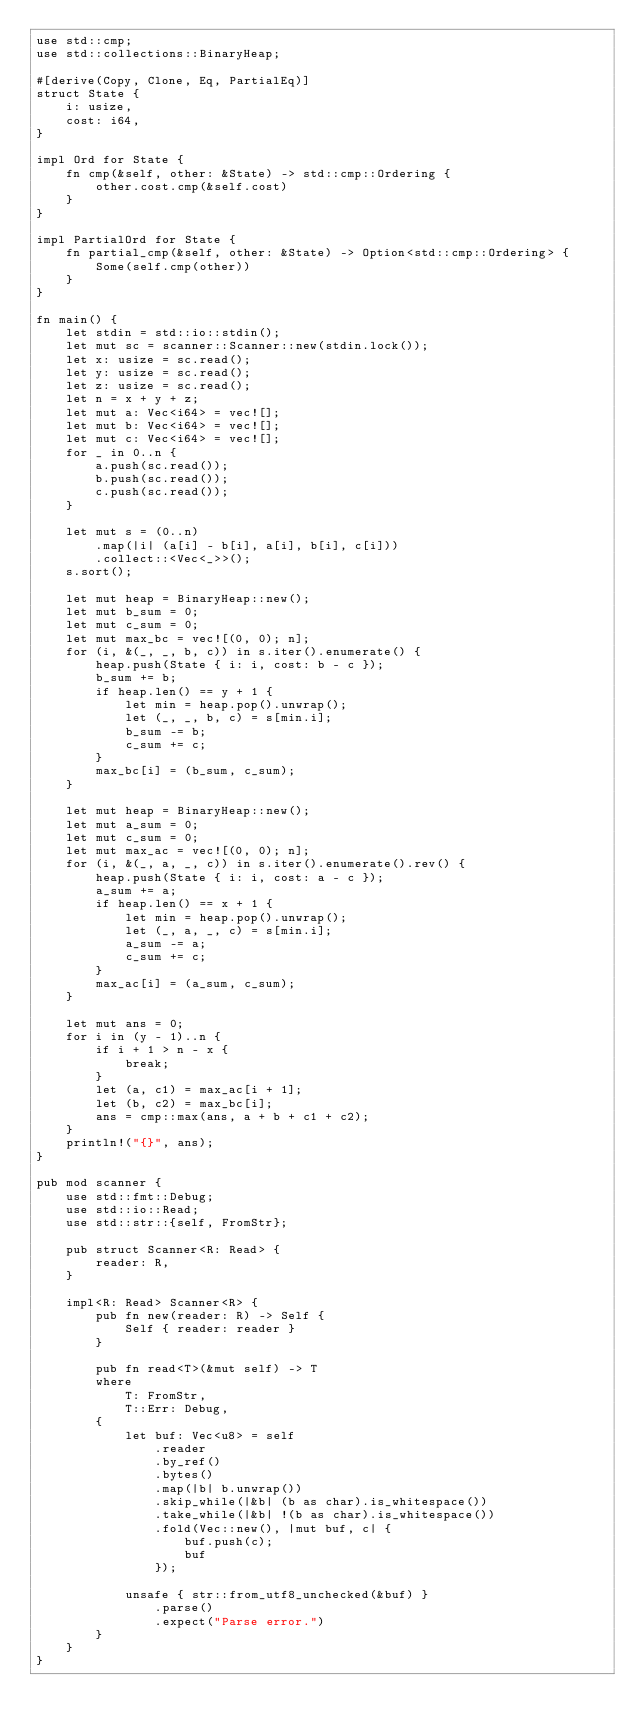<code> <loc_0><loc_0><loc_500><loc_500><_Rust_>use std::cmp;
use std::collections::BinaryHeap;

#[derive(Copy, Clone, Eq, PartialEq)]
struct State {
    i: usize,
    cost: i64,
}

impl Ord for State {
    fn cmp(&self, other: &State) -> std::cmp::Ordering {
        other.cost.cmp(&self.cost)
    }
}

impl PartialOrd for State {
    fn partial_cmp(&self, other: &State) -> Option<std::cmp::Ordering> {
        Some(self.cmp(other))
    }
}

fn main() {
    let stdin = std::io::stdin();
    let mut sc = scanner::Scanner::new(stdin.lock());
    let x: usize = sc.read();
    let y: usize = sc.read();
    let z: usize = sc.read();
    let n = x + y + z;
    let mut a: Vec<i64> = vec![];
    let mut b: Vec<i64> = vec![];
    let mut c: Vec<i64> = vec![];
    for _ in 0..n {
        a.push(sc.read());
        b.push(sc.read());
        c.push(sc.read());
    }

    let mut s = (0..n)
        .map(|i| (a[i] - b[i], a[i], b[i], c[i]))
        .collect::<Vec<_>>();
    s.sort();

    let mut heap = BinaryHeap::new();
    let mut b_sum = 0;
    let mut c_sum = 0;
    let mut max_bc = vec![(0, 0); n];
    for (i, &(_, _, b, c)) in s.iter().enumerate() {
        heap.push(State { i: i, cost: b - c });
        b_sum += b;
        if heap.len() == y + 1 {
            let min = heap.pop().unwrap();
            let (_, _, b, c) = s[min.i];
            b_sum -= b;
            c_sum += c;
        }
        max_bc[i] = (b_sum, c_sum);
    }

    let mut heap = BinaryHeap::new();
    let mut a_sum = 0;
    let mut c_sum = 0;
    let mut max_ac = vec![(0, 0); n];
    for (i, &(_, a, _, c)) in s.iter().enumerate().rev() {
        heap.push(State { i: i, cost: a - c });
        a_sum += a;
        if heap.len() == x + 1 {
            let min = heap.pop().unwrap();
            let (_, a, _, c) = s[min.i];
            a_sum -= a;
            c_sum += c;
        }
        max_ac[i] = (a_sum, c_sum);
    }

    let mut ans = 0;
    for i in (y - 1)..n {
        if i + 1 > n - x {
            break;
        }
        let (a, c1) = max_ac[i + 1];
        let (b, c2) = max_bc[i];
        ans = cmp::max(ans, a + b + c1 + c2);
    }
    println!("{}", ans);
}

pub mod scanner {
    use std::fmt::Debug;
    use std::io::Read;
    use std::str::{self, FromStr};

    pub struct Scanner<R: Read> {
        reader: R,
    }

    impl<R: Read> Scanner<R> {
        pub fn new(reader: R) -> Self {
            Self { reader: reader }
        }

        pub fn read<T>(&mut self) -> T
        where
            T: FromStr,
            T::Err: Debug,
        {
            let buf: Vec<u8> = self
                .reader
                .by_ref()
                .bytes()
                .map(|b| b.unwrap())
                .skip_while(|&b| (b as char).is_whitespace())
                .take_while(|&b| !(b as char).is_whitespace())
                .fold(Vec::new(), |mut buf, c| {
                    buf.push(c);
                    buf
                });

            unsafe { str::from_utf8_unchecked(&buf) }
                .parse()
                .expect("Parse error.")
        }
    }
}
</code> 